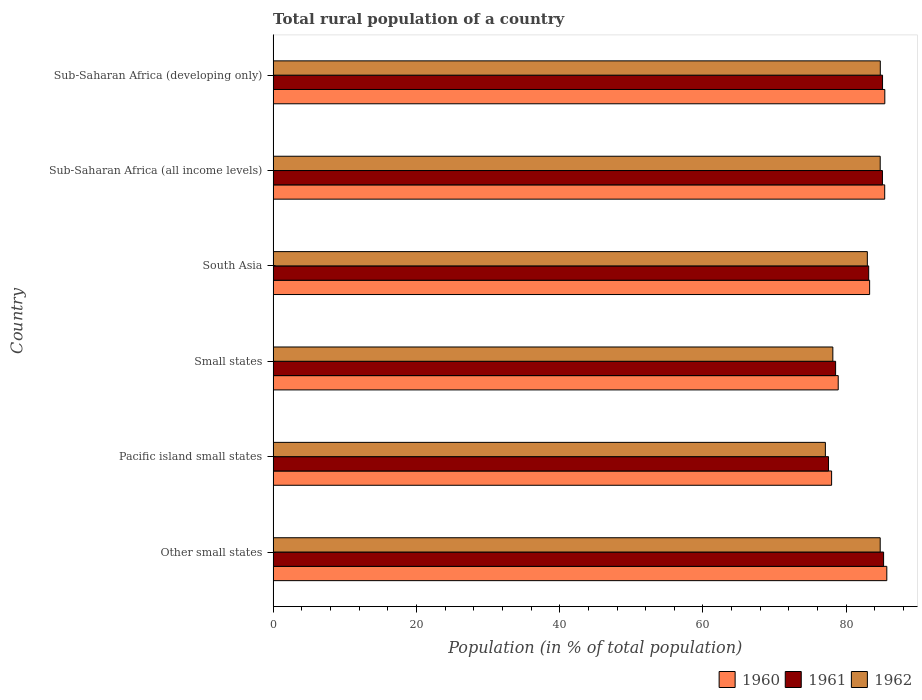How many different coloured bars are there?
Ensure brevity in your answer.  3. Are the number of bars per tick equal to the number of legend labels?
Your response must be concise. Yes. How many bars are there on the 2nd tick from the top?
Your response must be concise. 3. How many bars are there on the 1st tick from the bottom?
Offer a very short reply. 3. What is the label of the 6th group of bars from the top?
Provide a succinct answer. Other small states. What is the rural population in 1962 in South Asia?
Your response must be concise. 82.95. Across all countries, what is the maximum rural population in 1960?
Your answer should be compact. 85.66. Across all countries, what is the minimum rural population in 1961?
Offer a very short reply. 77.53. In which country was the rural population in 1961 maximum?
Give a very brief answer. Other small states. In which country was the rural population in 1960 minimum?
Ensure brevity in your answer.  Pacific island small states. What is the total rural population in 1960 in the graph?
Keep it short and to the point. 496.51. What is the difference between the rural population in 1962 in Other small states and that in South Asia?
Your answer should be very brief. 1.79. What is the difference between the rural population in 1960 in Sub-Saharan Africa (developing only) and the rural population in 1961 in Other small states?
Your response must be concise. 0.17. What is the average rural population in 1962 per country?
Provide a succinct answer. 82.07. What is the difference between the rural population in 1960 and rural population in 1962 in Sub-Saharan Africa (developing only)?
Your response must be concise. 0.63. What is the ratio of the rural population in 1961 in Other small states to that in Sub-Saharan Africa (developing only)?
Your answer should be compact. 1. Is the rural population in 1960 in Pacific island small states less than that in Small states?
Offer a terse response. Yes. Is the difference between the rural population in 1960 in Pacific island small states and South Asia greater than the difference between the rural population in 1962 in Pacific island small states and South Asia?
Your response must be concise. Yes. What is the difference between the highest and the second highest rural population in 1960?
Your answer should be very brief. 0.28. What is the difference between the highest and the lowest rural population in 1960?
Offer a very short reply. 7.71. In how many countries, is the rural population in 1961 greater than the average rural population in 1961 taken over all countries?
Give a very brief answer. 4. What does the 3rd bar from the top in Sub-Saharan Africa (developing only) represents?
Your answer should be compact. 1960. How many bars are there?
Provide a succinct answer. 18. Are all the bars in the graph horizontal?
Your answer should be very brief. Yes. How many countries are there in the graph?
Your answer should be compact. 6. Are the values on the major ticks of X-axis written in scientific E-notation?
Offer a terse response. No. Does the graph contain any zero values?
Offer a terse response. No. Does the graph contain grids?
Make the answer very short. No. Where does the legend appear in the graph?
Your response must be concise. Bottom right. How many legend labels are there?
Your response must be concise. 3. How are the legend labels stacked?
Your answer should be very brief. Horizontal. What is the title of the graph?
Your answer should be very brief. Total rural population of a country. What is the label or title of the X-axis?
Your answer should be compact. Population (in % of total population). What is the Population (in % of total population) of 1960 in Other small states?
Keep it short and to the point. 85.66. What is the Population (in % of total population) in 1961 in Other small states?
Provide a succinct answer. 85.21. What is the Population (in % of total population) in 1962 in Other small states?
Provide a short and direct response. 84.74. What is the Population (in % of total population) in 1960 in Pacific island small states?
Give a very brief answer. 77.96. What is the Population (in % of total population) in 1961 in Pacific island small states?
Offer a very short reply. 77.53. What is the Population (in % of total population) in 1962 in Pacific island small states?
Provide a succinct answer. 77.09. What is the Population (in % of total population) in 1960 in Small states?
Offer a terse response. 78.88. What is the Population (in % of total population) in 1961 in Small states?
Offer a very short reply. 78.52. What is the Population (in % of total population) in 1962 in Small states?
Make the answer very short. 78.13. What is the Population (in % of total population) of 1960 in South Asia?
Give a very brief answer. 83.26. What is the Population (in % of total population) of 1961 in South Asia?
Keep it short and to the point. 83.13. What is the Population (in % of total population) in 1962 in South Asia?
Give a very brief answer. 82.95. What is the Population (in % of total population) in 1960 in Sub-Saharan Africa (all income levels)?
Give a very brief answer. 85.37. What is the Population (in % of total population) in 1961 in Sub-Saharan Africa (all income levels)?
Make the answer very short. 85.05. What is the Population (in % of total population) of 1962 in Sub-Saharan Africa (all income levels)?
Give a very brief answer. 84.74. What is the Population (in % of total population) of 1960 in Sub-Saharan Africa (developing only)?
Keep it short and to the point. 85.38. What is the Population (in % of total population) of 1961 in Sub-Saharan Africa (developing only)?
Offer a very short reply. 85.07. What is the Population (in % of total population) of 1962 in Sub-Saharan Africa (developing only)?
Give a very brief answer. 84.75. Across all countries, what is the maximum Population (in % of total population) of 1960?
Make the answer very short. 85.66. Across all countries, what is the maximum Population (in % of total population) in 1961?
Provide a succinct answer. 85.21. Across all countries, what is the maximum Population (in % of total population) of 1962?
Ensure brevity in your answer.  84.75. Across all countries, what is the minimum Population (in % of total population) in 1960?
Ensure brevity in your answer.  77.96. Across all countries, what is the minimum Population (in % of total population) in 1961?
Offer a terse response. 77.53. Across all countries, what is the minimum Population (in % of total population) of 1962?
Your response must be concise. 77.09. What is the total Population (in % of total population) in 1960 in the graph?
Give a very brief answer. 496.51. What is the total Population (in % of total population) of 1961 in the graph?
Ensure brevity in your answer.  494.51. What is the total Population (in % of total population) of 1962 in the graph?
Keep it short and to the point. 492.39. What is the difference between the Population (in % of total population) in 1960 in Other small states and that in Pacific island small states?
Provide a short and direct response. 7.71. What is the difference between the Population (in % of total population) in 1961 in Other small states and that in Pacific island small states?
Your answer should be compact. 7.69. What is the difference between the Population (in % of total population) in 1962 in Other small states and that in Pacific island small states?
Your answer should be very brief. 7.65. What is the difference between the Population (in % of total population) of 1960 in Other small states and that in Small states?
Give a very brief answer. 6.78. What is the difference between the Population (in % of total population) in 1961 in Other small states and that in Small states?
Your response must be concise. 6.7. What is the difference between the Population (in % of total population) of 1962 in Other small states and that in Small states?
Your answer should be very brief. 6.61. What is the difference between the Population (in % of total population) of 1960 in Other small states and that in South Asia?
Provide a short and direct response. 2.4. What is the difference between the Population (in % of total population) in 1961 in Other small states and that in South Asia?
Offer a very short reply. 2.08. What is the difference between the Population (in % of total population) in 1962 in Other small states and that in South Asia?
Keep it short and to the point. 1.79. What is the difference between the Population (in % of total population) of 1960 in Other small states and that in Sub-Saharan Africa (all income levels)?
Your response must be concise. 0.29. What is the difference between the Population (in % of total population) of 1961 in Other small states and that in Sub-Saharan Africa (all income levels)?
Offer a very short reply. 0.16. What is the difference between the Population (in % of total population) in 1962 in Other small states and that in Sub-Saharan Africa (all income levels)?
Offer a very short reply. -0. What is the difference between the Population (in % of total population) of 1960 in Other small states and that in Sub-Saharan Africa (developing only)?
Offer a terse response. 0.28. What is the difference between the Population (in % of total population) in 1961 in Other small states and that in Sub-Saharan Africa (developing only)?
Your answer should be very brief. 0.15. What is the difference between the Population (in % of total population) in 1962 in Other small states and that in Sub-Saharan Africa (developing only)?
Provide a succinct answer. -0.01. What is the difference between the Population (in % of total population) of 1960 in Pacific island small states and that in Small states?
Offer a terse response. -0.92. What is the difference between the Population (in % of total population) in 1961 in Pacific island small states and that in Small states?
Your answer should be compact. -0.99. What is the difference between the Population (in % of total population) of 1962 in Pacific island small states and that in Small states?
Offer a terse response. -1.04. What is the difference between the Population (in % of total population) in 1960 in Pacific island small states and that in South Asia?
Your response must be concise. -5.31. What is the difference between the Population (in % of total population) of 1961 in Pacific island small states and that in South Asia?
Give a very brief answer. -5.61. What is the difference between the Population (in % of total population) in 1962 in Pacific island small states and that in South Asia?
Keep it short and to the point. -5.86. What is the difference between the Population (in % of total population) of 1960 in Pacific island small states and that in Sub-Saharan Africa (all income levels)?
Your response must be concise. -7.41. What is the difference between the Population (in % of total population) in 1961 in Pacific island small states and that in Sub-Saharan Africa (all income levels)?
Ensure brevity in your answer.  -7.53. What is the difference between the Population (in % of total population) of 1962 in Pacific island small states and that in Sub-Saharan Africa (all income levels)?
Offer a very short reply. -7.65. What is the difference between the Population (in % of total population) of 1960 in Pacific island small states and that in Sub-Saharan Africa (developing only)?
Offer a very short reply. -7.43. What is the difference between the Population (in % of total population) in 1961 in Pacific island small states and that in Sub-Saharan Africa (developing only)?
Offer a terse response. -7.54. What is the difference between the Population (in % of total population) in 1962 in Pacific island small states and that in Sub-Saharan Africa (developing only)?
Your answer should be compact. -7.67. What is the difference between the Population (in % of total population) in 1960 in Small states and that in South Asia?
Offer a terse response. -4.38. What is the difference between the Population (in % of total population) in 1961 in Small states and that in South Asia?
Keep it short and to the point. -4.62. What is the difference between the Population (in % of total population) of 1962 in Small states and that in South Asia?
Ensure brevity in your answer.  -4.82. What is the difference between the Population (in % of total population) of 1960 in Small states and that in Sub-Saharan Africa (all income levels)?
Make the answer very short. -6.49. What is the difference between the Population (in % of total population) in 1961 in Small states and that in Sub-Saharan Africa (all income levels)?
Keep it short and to the point. -6.54. What is the difference between the Population (in % of total population) of 1962 in Small states and that in Sub-Saharan Africa (all income levels)?
Your answer should be very brief. -6.61. What is the difference between the Population (in % of total population) in 1960 in Small states and that in Sub-Saharan Africa (developing only)?
Your answer should be compact. -6.5. What is the difference between the Population (in % of total population) in 1961 in Small states and that in Sub-Saharan Africa (developing only)?
Give a very brief answer. -6.55. What is the difference between the Population (in % of total population) in 1962 in Small states and that in Sub-Saharan Africa (developing only)?
Make the answer very short. -6.63. What is the difference between the Population (in % of total population) of 1960 in South Asia and that in Sub-Saharan Africa (all income levels)?
Give a very brief answer. -2.1. What is the difference between the Population (in % of total population) of 1961 in South Asia and that in Sub-Saharan Africa (all income levels)?
Offer a very short reply. -1.92. What is the difference between the Population (in % of total population) of 1962 in South Asia and that in Sub-Saharan Africa (all income levels)?
Make the answer very short. -1.79. What is the difference between the Population (in % of total population) in 1960 in South Asia and that in Sub-Saharan Africa (developing only)?
Keep it short and to the point. -2.12. What is the difference between the Population (in % of total population) of 1961 in South Asia and that in Sub-Saharan Africa (developing only)?
Your response must be concise. -1.93. What is the difference between the Population (in % of total population) of 1962 in South Asia and that in Sub-Saharan Africa (developing only)?
Provide a short and direct response. -1.81. What is the difference between the Population (in % of total population) in 1960 in Sub-Saharan Africa (all income levels) and that in Sub-Saharan Africa (developing only)?
Keep it short and to the point. -0.01. What is the difference between the Population (in % of total population) in 1961 in Sub-Saharan Africa (all income levels) and that in Sub-Saharan Africa (developing only)?
Your answer should be compact. -0.01. What is the difference between the Population (in % of total population) of 1962 in Sub-Saharan Africa (all income levels) and that in Sub-Saharan Africa (developing only)?
Provide a succinct answer. -0.01. What is the difference between the Population (in % of total population) in 1960 in Other small states and the Population (in % of total population) in 1961 in Pacific island small states?
Provide a short and direct response. 8.14. What is the difference between the Population (in % of total population) of 1960 in Other small states and the Population (in % of total population) of 1962 in Pacific island small states?
Ensure brevity in your answer.  8.58. What is the difference between the Population (in % of total population) of 1961 in Other small states and the Population (in % of total population) of 1962 in Pacific island small states?
Keep it short and to the point. 8.13. What is the difference between the Population (in % of total population) of 1960 in Other small states and the Population (in % of total population) of 1961 in Small states?
Make the answer very short. 7.15. What is the difference between the Population (in % of total population) in 1960 in Other small states and the Population (in % of total population) in 1962 in Small states?
Keep it short and to the point. 7.53. What is the difference between the Population (in % of total population) of 1961 in Other small states and the Population (in % of total population) of 1962 in Small states?
Offer a very short reply. 7.09. What is the difference between the Population (in % of total population) in 1960 in Other small states and the Population (in % of total population) in 1961 in South Asia?
Provide a succinct answer. 2.53. What is the difference between the Population (in % of total population) in 1960 in Other small states and the Population (in % of total population) in 1962 in South Asia?
Your answer should be compact. 2.72. What is the difference between the Population (in % of total population) of 1961 in Other small states and the Population (in % of total population) of 1962 in South Asia?
Ensure brevity in your answer.  2.27. What is the difference between the Population (in % of total population) in 1960 in Other small states and the Population (in % of total population) in 1961 in Sub-Saharan Africa (all income levels)?
Your answer should be very brief. 0.61. What is the difference between the Population (in % of total population) of 1960 in Other small states and the Population (in % of total population) of 1962 in Sub-Saharan Africa (all income levels)?
Provide a succinct answer. 0.92. What is the difference between the Population (in % of total population) in 1961 in Other small states and the Population (in % of total population) in 1962 in Sub-Saharan Africa (all income levels)?
Ensure brevity in your answer.  0.47. What is the difference between the Population (in % of total population) in 1960 in Other small states and the Population (in % of total population) in 1961 in Sub-Saharan Africa (developing only)?
Give a very brief answer. 0.59. What is the difference between the Population (in % of total population) in 1960 in Other small states and the Population (in % of total population) in 1962 in Sub-Saharan Africa (developing only)?
Your response must be concise. 0.91. What is the difference between the Population (in % of total population) of 1961 in Other small states and the Population (in % of total population) of 1962 in Sub-Saharan Africa (developing only)?
Make the answer very short. 0.46. What is the difference between the Population (in % of total population) of 1960 in Pacific island small states and the Population (in % of total population) of 1961 in Small states?
Give a very brief answer. -0.56. What is the difference between the Population (in % of total population) in 1960 in Pacific island small states and the Population (in % of total population) in 1962 in Small states?
Your answer should be compact. -0.17. What is the difference between the Population (in % of total population) in 1961 in Pacific island small states and the Population (in % of total population) in 1962 in Small states?
Provide a succinct answer. -0.6. What is the difference between the Population (in % of total population) of 1960 in Pacific island small states and the Population (in % of total population) of 1961 in South Asia?
Offer a terse response. -5.18. What is the difference between the Population (in % of total population) of 1960 in Pacific island small states and the Population (in % of total population) of 1962 in South Asia?
Your response must be concise. -4.99. What is the difference between the Population (in % of total population) in 1961 in Pacific island small states and the Population (in % of total population) in 1962 in South Asia?
Offer a very short reply. -5.42. What is the difference between the Population (in % of total population) of 1960 in Pacific island small states and the Population (in % of total population) of 1961 in Sub-Saharan Africa (all income levels)?
Your answer should be very brief. -7.1. What is the difference between the Population (in % of total population) in 1960 in Pacific island small states and the Population (in % of total population) in 1962 in Sub-Saharan Africa (all income levels)?
Provide a succinct answer. -6.78. What is the difference between the Population (in % of total population) in 1961 in Pacific island small states and the Population (in % of total population) in 1962 in Sub-Saharan Africa (all income levels)?
Offer a terse response. -7.21. What is the difference between the Population (in % of total population) in 1960 in Pacific island small states and the Population (in % of total population) in 1961 in Sub-Saharan Africa (developing only)?
Ensure brevity in your answer.  -7.11. What is the difference between the Population (in % of total population) in 1960 in Pacific island small states and the Population (in % of total population) in 1962 in Sub-Saharan Africa (developing only)?
Make the answer very short. -6.8. What is the difference between the Population (in % of total population) in 1961 in Pacific island small states and the Population (in % of total population) in 1962 in Sub-Saharan Africa (developing only)?
Give a very brief answer. -7.23. What is the difference between the Population (in % of total population) of 1960 in Small states and the Population (in % of total population) of 1961 in South Asia?
Provide a short and direct response. -4.25. What is the difference between the Population (in % of total population) of 1960 in Small states and the Population (in % of total population) of 1962 in South Asia?
Offer a very short reply. -4.07. What is the difference between the Population (in % of total population) of 1961 in Small states and the Population (in % of total population) of 1962 in South Asia?
Your answer should be very brief. -4.43. What is the difference between the Population (in % of total population) in 1960 in Small states and the Population (in % of total population) in 1961 in Sub-Saharan Africa (all income levels)?
Offer a very short reply. -6.17. What is the difference between the Population (in % of total population) in 1960 in Small states and the Population (in % of total population) in 1962 in Sub-Saharan Africa (all income levels)?
Provide a short and direct response. -5.86. What is the difference between the Population (in % of total population) of 1961 in Small states and the Population (in % of total population) of 1962 in Sub-Saharan Africa (all income levels)?
Provide a succinct answer. -6.22. What is the difference between the Population (in % of total population) in 1960 in Small states and the Population (in % of total population) in 1961 in Sub-Saharan Africa (developing only)?
Offer a terse response. -6.19. What is the difference between the Population (in % of total population) in 1960 in Small states and the Population (in % of total population) in 1962 in Sub-Saharan Africa (developing only)?
Keep it short and to the point. -5.87. What is the difference between the Population (in % of total population) of 1961 in Small states and the Population (in % of total population) of 1962 in Sub-Saharan Africa (developing only)?
Ensure brevity in your answer.  -6.24. What is the difference between the Population (in % of total population) of 1960 in South Asia and the Population (in % of total population) of 1961 in Sub-Saharan Africa (all income levels)?
Offer a terse response. -1.79. What is the difference between the Population (in % of total population) of 1960 in South Asia and the Population (in % of total population) of 1962 in Sub-Saharan Africa (all income levels)?
Provide a succinct answer. -1.48. What is the difference between the Population (in % of total population) in 1961 in South Asia and the Population (in % of total population) in 1962 in Sub-Saharan Africa (all income levels)?
Make the answer very short. -1.61. What is the difference between the Population (in % of total population) of 1960 in South Asia and the Population (in % of total population) of 1961 in Sub-Saharan Africa (developing only)?
Your answer should be very brief. -1.8. What is the difference between the Population (in % of total population) of 1960 in South Asia and the Population (in % of total population) of 1962 in Sub-Saharan Africa (developing only)?
Give a very brief answer. -1.49. What is the difference between the Population (in % of total population) in 1961 in South Asia and the Population (in % of total population) in 1962 in Sub-Saharan Africa (developing only)?
Offer a very short reply. -1.62. What is the difference between the Population (in % of total population) in 1960 in Sub-Saharan Africa (all income levels) and the Population (in % of total population) in 1961 in Sub-Saharan Africa (developing only)?
Provide a succinct answer. 0.3. What is the difference between the Population (in % of total population) of 1960 in Sub-Saharan Africa (all income levels) and the Population (in % of total population) of 1962 in Sub-Saharan Africa (developing only)?
Provide a short and direct response. 0.61. What is the difference between the Population (in % of total population) of 1961 in Sub-Saharan Africa (all income levels) and the Population (in % of total population) of 1962 in Sub-Saharan Africa (developing only)?
Offer a terse response. 0.3. What is the average Population (in % of total population) of 1960 per country?
Ensure brevity in your answer.  82.75. What is the average Population (in % of total population) of 1961 per country?
Provide a short and direct response. 82.42. What is the average Population (in % of total population) of 1962 per country?
Provide a succinct answer. 82.07. What is the difference between the Population (in % of total population) of 1960 and Population (in % of total population) of 1961 in Other small states?
Ensure brevity in your answer.  0.45. What is the difference between the Population (in % of total population) in 1960 and Population (in % of total population) in 1962 in Other small states?
Offer a very short reply. 0.92. What is the difference between the Population (in % of total population) of 1961 and Population (in % of total population) of 1962 in Other small states?
Make the answer very short. 0.47. What is the difference between the Population (in % of total population) in 1960 and Population (in % of total population) in 1961 in Pacific island small states?
Your answer should be very brief. 0.43. What is the difference between the Population (in % of total population) of 1960 and Population (in % of total population) of 1962 in Pacific island small states?
Your answer should be very brief. 0.87. What is the difference between the Population (in % of total population) in 1961 and Population (in % of total population) in 1962 in Pacific island small states?
Provide a short and direct response. 0.44. What is the difference between the Population (in % of total population) of 1960 and Population (in % of total population) of 1961 in Small states?
Offer a terse response. 0.36. What is the difference between the Population (in % of total population) in 1960 and Population (in % of total population) in 1962 in Small states?
Make the answer very short. 0.75. What is the difference between the Population (in % of total population) in 1961 and Population (in % of total population) in 1962 in Small states?
Your answer should be very brief. 0.39. What is the difference between the Population (in % of total population) in 1960 and Population (in % of total population) in 1961 in South Asia?
Ensure brevity in your answer.  0.13. What is the difference between the Population (in % of total population) of 1960 and Population (in % of total population) of 1962 in South Asia?
Make the answer very short. 0.32. What is the difference between the Population (in % of total population) in 1961 and Population (in % of total population) in 1962 in South Asia?
Give a very brief answer. 0.19. What is the difference between the Population (in % of total population) in 1960 and Population (in % of total population) in 1961 in Sub-Saharan Africa (all income levels)?
Offer a terse response. 0.32. What is the difference between the Population (in % of total population) in 1960 and Population (in % of total population) in 1962 in Sub-Saharan Africa (all income levels)?
Make the answer very short. 0.63. What is the difference between the Population (in % of total population) in 1961 and Population (in % of total population) in 1962 in Sub-Saharan Africa (all income levels)?
Ensure brevity in your answer.  0.31. What is the difference between the Population (in % of total population) in 1960 and Population (in % of total population) in 1961 in Sub-Saharan Africa (developing only)?
Your answer should be very brief. 0.32. What is the difference between the Population (in % of total population) of 1960 and Population (in % of total population) of 1962 in Sub-Saharan Africa (developing only)?
Make the answer very short. 0.63. What is the difference between the Population (in % of total population) of 1961 and Population (in % of total population) of 1962 in Sub-Saharan Africa (developing only)?
Offer a very short reply. 0.31. What is the ratio of the Population (in % of total population) of 1960 in Other small states to that in Pacific island small states?
Offer a terse response. 1.1. What is the ratio of the Population (in % of total population) in 1961 in Other small states to that in Pacific island small states?
Offer a terse response. 1.1. What is the ratio of the Population (in % of total population) in 1962 in Other small states to that in Pacific island small states?
Make the answer very short. 1.1. What is the ratio of the Population (in % of total population) in 1960 in Other small states to that in Small states?
Keep it short and to the point. 1.09. What is the ratio of the Population (in % of total population) in 1961 in Other small states to that in Small states?
Your answer should be compact. 1.09. What is the ratio of the Population (in % of total population) in 1962 in Other small states to that in Small states?
Your answer should be very brief. 1.08. What is the ratio of the Population (in % of total population) of 1960 in Other small states to that in South Asia?
Offer a terse response. 1.03. What is the ratio of the Population (in % of total population) in 1962 in Other small states to that in South Asia?
Ensure brevity in your answer.  1.02. What is the ratio of the Population (in % of total population) of 1962 in Other small states to that in Sub-Saharan Africa (developing only)?
Make the answer very short. 1. What is the ratio of the Population (in % of total population) in 1960 in Pacific island small states to that in Small states?
Your answer should be very brief. 0.99. What is the ratio of the Population (in % of total population) in 1961 in Pacific island small states to that in Small states?
Your answer should be compact. 0.99. What is the ratio of the Population (in % of total population) in 1962 in Pacific island small states to that in Small states?
Your answer should be compact. 0.99. What is the ratio of the Population (in % of total population) in 1960 in Pacific island small states to that in South Asia?
Offer a very short reply. 0.94. What is the ratio of the Population (in % of total population) of 1961 in Pacific island small states to that in South Asia?
Your answer should be very brief. 0.93. What is the ratio of the Population (in % of total population) of 1962 in Pacific island small states to that in South Asia?
Give a very brief answer. 0.93. What is the ratio of the Population (in % of total population) of 1960 in Pacific island small states to that in Sub-Saharan Africa (all income levels)?
Provide a short and direct response. 0.91. What is the ratio of the Population (in % of total population) in 1961 in Pacific island small states to that in Sub-Saharan Africa (all income levels)?
Offer a very short reply. 0.91. What is the ratio of the Population (in % of total population) of 1962 in Pacific island small states to that in Sub-Saharan Africa (all income levels)?
Your answer should be very brief. 0.91. What is the ratio of the Population (in % of total population) of 1960 in Pacific island small states to that in Sub-Saharan Africa (developing only)?
Your answer should be very brief. 0.91. What is the ratio of the Population (in % of total population) in 1961 in Pacific island small states to that in Sub-Saharan Africa (developing only)?
Your response must be concise. 0.91. What is the ratio of the Population (in % of total population) of 1962 in Pacific island small states to that in Sub-Saharan Africa (developing only)?
Offer a terse response. 0.91. What is the ratio of the Population (in % of total population) of 1960 in Small states to that in South Asia?
Your answer should be very brief. 0.95. What is the ratio of the Population (in % of total population) in 1961 in Small states to that in South Asia?
Your response must be concise. 0.94. What is the ratio of the Population (in % of total population) in 1962 in Small states to that in South Asia?
Make the answer very short. 0.94. What is the ratio of the Population (in % of total population) in 1960 in Small states to that in Sub-Saharan Africa (all income levels)?
Ensure brevity in your answer.  0.92. What is the ratio of the Population (in % of total population) in 1961 in Small states to that in Sub-Saharan Africa (all income levels)?
Your response must be concise. 0.92. What is the ratio of the Population (in % of total population) of 1962 in Small states to that in Sub-Saharan Africa (all income levels)?
Your response must be concise. 0.92. What is the ratio of the Population (in % of total population) in 1960 in Small states to that in Sub-Saharan Africa (developing only)?
Provide a short and direct response. 0.92. What is the ratio of the Population (in % of total population) in 1961 in Small states to that in Sub-Saharan Africa (developing only)?
Your response must be concise. 0.92. What is the ratio of the Population (in % of total population) of 1962 in Small states to that in Sub-Saharan Africa (developing only)?
Ensure brevity in your answer.  0.92. What is the ratio of the Population (in % of total population) in 1960 in South Asia to that in Sub-Saharan Africa (all income levels)?
Offer a terse response. 0.98. What is the ratio of the Population (in % of total population) of 1961 in South Asia to that in Sub-Saharan Africa (all income levels)?
Provide a short and direct response. 0.98. What is the ratio of the Population (in % of total population) of 1962 in South Asia to that in Sub-Saharan Africa (all income levels)?
Offer a terse response. 0.98. What is the ratio of the Population (in % of total population) of 1960 in South Asia to that in Sub-Saharan Africa (developing only)?
Your answer should be very brief. 0.98. What is the ratio of the Population (in % of total population) in 1961 in South Asia to that in Sub-Saharan Africa (developing only)?
Provide a succinct answer. 0.98. What is the ratio of the Population (in % of total population) in 1962 in South Asia to that in Sub-Saharan Africa (developing only)?
Your answer should be very brief. 0.98. What is the ratio of the Population (in % of total population) of 1960 in Sub-Saharan Africa (all income levels) to that in Sub-Saharan Africa (developing only)?
Ensure brevity in your answer.  1. What is the ratio of the Population (in % of total population) of 1961 in Sub-Saharan Africa (all income levels) to that in Sub-Saharan Africa (developing only)?
Make the answer very short. 1. What is the ratio of the Population (in % of total population) in 1962 in Sub-Saharan Africa (all income levels) to that in Sub-Saharan Africa (developing only)?
Ensure brevity in your answer.  1. What is the difference between the highest and the second highest Population (in % of total population) of 1960?
Offer a very short reply. 0.28. What is the difference between the highest and the second highest Population (in % of total population) of 1961?
Offer a terse response. 0.15. What is the difference between the highest and the second highest Population (in % of total population) of 1962?
Make the answer very short. 0.01. What is the difference between the highest and the lowest Population (in % of total population) of 1960?
Provide a short and direct response. 7.71. What is the difference between the highest and the lowest Population (in % of total population) of 1961?
Give a very brief answer. 7.69. What is the difference between the highest and the lowest Population (in % of total population) in 1962?
Provide a succinct answer. 7.67. 